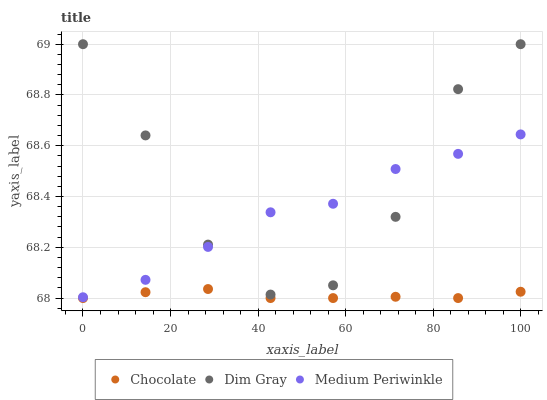Does Chocolate have the minimum area under the curve?
Answer yes or no. Yes. Does Dim Gray have the maximum area under the curve?
Answer yes or no. Yes. Does Medium Periwinkle have the minimum area under the curve?
Answer yes or no. No. Does Medium Periwinkle have the maximum area under the curve?
Answer yes or no. No. Is Chocolate the smoothest?
Answer yes or no. Yes. Is Dim Gray the roughest?
Answer yes or no. Yes. Is Medium Periwinkle the smoothest?
Answer yes or no. No. Is Medium Periwinkle the roughest?
Answer yes or no. No. Does Chocolate have the lowest value?
Answer yes or no. Yes. Does Medium Periwinkle have the lowest value?
Answer yes or no. No. Does Dim Gray have the highest value?
Answer yes or no. Yes. Does Medium Periwinkle have the highest value?
Answer yes or no. No. Is Chocolate less than Medium Periwinkle?
Answer yes or no. Yes. Is Dim Gray greater than Chocolate?
Answer yes or no. Yes. Does Dim Gray intersect Medium Periwinkle?
Answer yes or no. Yes. Is Dim Gray less than Medium Periwinkle?
Answer yes or no. No. Is Dim Gray greater than Medium Periwinkle?
Answer yes or no. No. Does Chocolate intersect Medium Periwinkle?
Answer yes or no. No. 